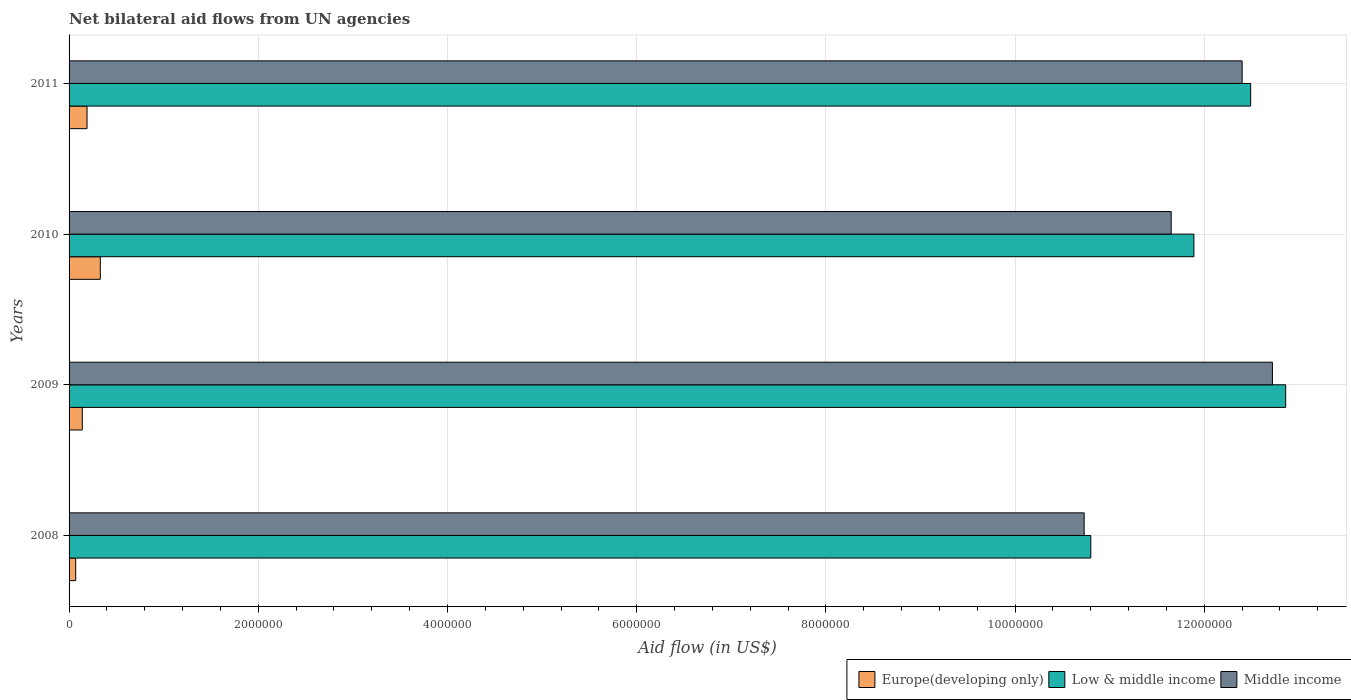How many different coloured bars are there?
Your response must be concise. 3. How many groups of bars are there?
Provide a short and direct response. 4. Are the number of bars per tick equal to the number of legend labels?
Your response must be concise. Yes. Are the number of bars on each tick of the Y-axis equal?
Ensure brevity in your answer.  Yes. How many bars are there on the 3rd tick from the top?
Offer a terse response. 3. What is the label of the 3rd group of bars from the top?
Make the answer very short. 2009. What is the net bilateral aid flow in Middle income in 2008?
Offer a very short reply. 1.07e+07. Across all years, what is the maximum net bilateral aid flow in Europe(developing only)?
Offer a terse response. 3.30e+05. Across all years, what is the minimum net bilateral aid flow in Low & middle income?
Provide a succinct answer. 1.08e+07. In which year was the net bilateral aid flow in Middle income maximum?
Keep it short and to the point. 2009. In which year was the net bilateral aid flow in Europe(developing only) minimum?
Make the answer very short. 2008. What is the total net bilateral aid flow in Europe(developing only) in the graph?
Ensure brevity in your answer.  7.30e+05. What is the difference between the net bilateral aid flow in Low & middle income in 2008 and that in 2009?
Your answer should be very brief. -2.06e+06. What is the difference between the net bilateral aid flow in Middle income in 2010 and the net bilateral aid flow in Europe(developing only) in 2008?
Provide a succinct answer. 1.16e+07. What is the average net bilateral aid flow in Europe(developing only) per year?
Provide a succinct answer. 1.82e+05. In the year 2009, what is the difference between the net bilateral aid flow in Low & middle income and net bilateral aid flow in Middle income?
Give a very brief answer. 1.40e+05. What is the ratio of the net bilateral aid flow in Middle income in 2008 to that in 2009?
Give a very brief answer. 0.84. Is the difference between the net bilateral aid flow in Low & middle income in 2009 and 2010 greater than the difference between the net bilateral aid flow in Middle income in 2009 and 2010?
Offer a very short reply. No. What is the difference between the highest and the lowest net bilateral aid flow in Low & middle income?
Make the answer very short. 2.06e+06. In how many years, is the net bilateral aid flow in Middle income greater than the average net bilateral aid flow in Middle income taken over all years?
Offer a very short reply. 2. Is the sum of the net bilateral aid flow in Middle income in 2009 and 2010 greater than the maximum net bilateral aid flow in Europe(developing only) across all years?
Offer a terse response. Yes. How many bars are there?
Your answer should be compact. 12. Are all the bars in the graph horizontal?
Your answer should be very brief. Yes. How many years are there in the graph?
Offer a very short reply. 4. Are the values on the major ticks of X-axis written in scientific E-notation?
Your response must be concise. No. Where does the legend appear in the graph?
Ensure brevity in your answer.  Bottom right. What is the title of the graph?
Your answer should be compact. Net bilateral aid flows from UN agencies. What is the label or title of the X-axis?
Make the answer very short. Aid flow (in US$). What is the label or title of the Y-axis?
Offer a terse response. Years. What is the Aid flow (in US$) of Low & middle income in 2008?
Ensure brevity in your answer.  1.08e+07. What is the Aid flow (in US$) of Middle income in 2008?
Make the answer very short. 1.07e+07. What is the Aid flow (in US$) of Europe(developing only) in 2009?
Your answer should be very brief. 1.40e+05. What is the Aid flow (in US$) of Low & middle income in 2009?
Your response must be concise. 1.29e+07. What is the Aid flow (in US$) in Middle income in 2009?
Your answer should be compact. 1.27e+07. What is the Aid flow (in US$) in Low & middle income in 2010?
Provide a short and direct response. 1.19e+07. What is the Aid flow (in US$) of Middle income in 2010?
Your answer should be compact. 1.16e+07. What is the Aid flow (in US$) of Europe(developing only) in 2011?
Offer a very short reply. 1.90e+05. What is the Aid flow (in US$) in Low & middle income in 2011?
Make the answer very short. 1.25e+07. What is the Aid flow (in US$) of Middle income in 2011?
Offer a terse response. 1.24e+07. Across all years, what is the maximum Aid flow (in US$) of Low & middle income?
Provide a succinct answer. 1.29e+07. Across all years, what is the maximum Aid flow (in US$) of Middle income?
Make the answer very short. 1.27e+07. Across all years, what is the minimum Aid flow (in US$) of Europe(developing only)?
Give a very brief answer. 7.00e+04. Across all years, what is the minimum Aid flow (in US$) in Low & middle income?
Offer a terse response. 1.08e+07. Across all years, what is the minimum Aid flow (in US$) in Middle income?
Provide a succinct answer. 1.07e+07. What is the total Aid flow (in US$) in Europe(developing only) in the graph?
Your answer should be very brief. 7.30e+05. What is the total Aid flow (in US$) in Low & middle income in the graph?
Your answer should be compact. 4.80e+07. What is the total Aid flow (in US$) in Middle income in the graph?
Make the answer very short. 4.75e+07. What is the difference between the Aid flow (in US$) in Europe(developing only) in 2008 and that in 2009?
Keep it short and to the point. -7.00e+04. What is the difference between the Aid flow (in US$) of Low & middle income in 2008 and that in 2009?
Offer a very short reply. -2.06e+06. What is the difference between the Aid flow (in US$) of Middle income in 2008 and that in 2009?
Provide a succinct answer. -1.99e+06. What is the difference between the Aid flow (in US$) in Europe(developing only) in 2008 and that in 2010?
Offer a terse response. -2.60e+05. What is the difference between the Aid flow (in US$) of Low & middle income in 2008 and that in 2010?
Keep it short and to the point. -1.09e+06. What is the difference between the Aid flow (in US$) in Middle income in 2008 and that in 2010?
Offer a terse response. -9.20e+05. What is the difference between the Aid flow (in US$) of Europe(developing only) in 2008 and that in 2011?
Offer a terse response. -1.20e+05. What is the difference between the Aid flow (in US$) of Low & middle income in 2008 and that in 2011?
Your response must be concise. -1.69e+06. What is the difference between the Aid flow (in US$) in Middle income in 2008 and that in 2011?
Give a very brief answer. -1.67e+06. What is the difference between the Aid flow (in US$) of Low & middle income in 2009 and that in 2010?
Ensure brevity in your answer.  9.70e+05. What is the difference between the Aid flow (in US$) in Middle income in 2009 and that in 2010?
Your answer should be very brief. 1.07e+06. What is the difference between the Aid flow (in US$) of Europe(developing only) in 2009 and that in 2011?
Provide a short and direct response. -5.00e+04. What is the difference between the Aid flow (in US$) in Middle income in 2009 and that in 2011?
Ensure brevity in your answer.  3.20e+05. What is the difference between the Aid flow (in US$) in Low & middle income in 2010 and that in 2011?
Ensure brevity in your answer.  -6.00e+05. What is the difference between the Aid flow (in US$) of Middle income in 2010 and that in 2011?
Keep it short and to the point. -7.50e+05. What is the difference between the Aid flow (in US$) in Europe(developing only) in 2008 and the Aid flow (in US$) in Low & middle income in 2009?
Your answer should be compact. -1.28e+07. What is the difference between the Aid flow (in US$) in Europe(developing only) in 2008 and the Aid flow (in US$) in Middle income in 2009?
Give a very brief answer. -1.26e+07. What is the difference between the Aid flow (in US$) of Low & middle income in 2008 and the Aid flow (in US$) of Middle income in 2009?
Provide a short and direct response. -1.92e+06. What is the difference between the Aid flow (in US$) in Europe(developing only) in 2008 and the Aid flow (in US$) in Low & middle income in 2010?
Your answer should be compact. -1.18e+07. What is the difference between the Aid flow (in US$) of Europe(developing only) in 2008 and the Aid flow (in US$) of Middle income in 2010?
Provide a succinct answer. -1.16e+07. What is the difference between the Aid flow (in US$) in Low & middle income in 2008 and the Aid flow (in US$) in Middle income in 2010?
Your response must be concise. -8.50e+05. What is the difference between the Aid flow (in US$) in Europe(developing only) in 2008 and the Aid flow (in US$) in Low & middle income in 2011?
Provide a short and direct response. -1.24e+07. What is the difference between the Aid flow (in US$) of Europe(developing only) in 2008 and the Aid flow (in US$) of Middle income in 2011?
Your response must be concise. -1.23e+07. What is the difference between the Aid flow (in US$) in Low & middle income in 2008 and the Aid flow (in US$) in Middle income in 2011?
Ensure brevity in your answer.  -1.60e+06. What is the difference between the Aid flow (in US$) in Europe(developing only) in 2009 and the Aid flow (in US$) in Low & middle income in 2010?
Give a very brief answer. -1.18e+07. What is the difference between the Aid flow (in US$) in Europe(developing only) in 2009 and the Aid flow (in US$) in Middle income in 2010?
Your answer should be very brief. -1.15e+07. What is the difference between the Aid flow (in US$) of Low & middle income in 2009 and the Aid flow (in US$) of Middle income in 2010?
Your answer should be very brief. 1.21e+06. What is the difference between the Aid flow (in US$) in Europe(developing only) in 2009 and the Aid flow (in US$) in Low & middle income in 2011?
Offer a terse response. -1.24e+07. What is the difference between the Aid flow (in US$) in Europe(developing only) in 2009 and the Aid flow (in US$) in Middle income in 2011?
Your answer should be very brief. -1.23e+07. What is the difference between the Aid flow (in US$) in Europe(developing only) in 2010 and the Aid flow (in US$) in Low & middle income in 2011?
Offer a terse response. -1.22e+07. What is the difference between the Aid flow (in US$) of Europe(developing only) in 2010 and the Aid flow (in US$) of Middle income in 2011?
Provide a short and direct response. -1.21e+07. What is the difference between the Aid flow (in US$) in Low & middle income in 2010 and the Aid flow (in US$) in Middle income in 2011?
Your answer should be compact. -5.10e+05. What is the average Aid flow (in US$) in Europe(developing only) per year?
Offer a terse response. 1.82e+05. What is the average Aid flow (in US$) of Low & middle income per year?
Ensure brevity in your answer.  1.20e+07. What is the average Aid flow (in US$) of Middle income per year?
Make the answer very short. 1.19e+07. In the year 2008, what is the difference between the Aid flow (in US$) in Europe(developing only) and Aid flow (in US$) in Low & middle income?
Keep it short and to the point. -1.07e+07. In the year 2008, what is the difference between the Aid flow (in US$) in Europe(developing only) and Aid flow (in US$) in Middle income?
Offer a very short reply. -1.07e+07. In the year 2009, what is the difference between the Aid flow (in US$) of Europe(developing only) and Aid flow (in US$) of Low & middle income?
Provide a succinct answer. -1.27e+07. In the year 2009, what is the difference between the Aid flow (in US$) in Europe(developing only) and Aid flow (in US$) in Middle income?
Keep it short and to the point. -1.26e+07. In the year 2009, what is the difference between the Aid flow (in US$) in Low & middle income and Aid flow (in US$) in Middle income?
Make the answer very short. 1.40e+05. In the year 2010, what is the difference between the Aid flow (in US$) of Europe(developing only) and Aid flow (in US$) of Low & middle income?
Give a very brief answer. -1.16e+07. In the year 2010, what is the difference between the Aid flow (in US$) of Europe(developing only) and Aid flow (in US$) of Middle income?
Provide a succinct answer. -1.13e+07. In the year 2010, what is the difference between the Aid flow (in US$) of Low & middle income and Aid flow (in US$) of Middle income?
Ensure brevity in your answer.  2.40e+05. In the year 2011, what is the difference between the Aid flow (in US$) in Europe(developing only) and Aid flow (in US$) in Low & middle income?
Keep it short and to the point. -1.23e+07. In the year 2011, what is the difference between the Aid flow (in US$) in Europe(developing only) and Aid flow (in US$) in Middle income?
Keep it short and to the point. -1.22e+07. What is the ratio of the Aid flow (in US$) of Europe(developing only) in 2008 to that in 2009?
Give a very brief answer. 0.5. What is the ratio of the Aid flow (in US$) in Low & middle income in 2008 to that in 2009?
Ensure brevity in your answer.  0.84. What is the ratio of the Aid flow (in US$) of Middle income in 2008 to that in 2009?
Make the answer very short. 0.84. What is the ratio of the Aid flow (in US$) in Europe(developing only) in 2008 to that in 2010?
Your answer should be compact. 0.21. What is the ratio of the Aid flow (in US$) of Low & middle income in 2008 to that in 2010?
Your answer should be very brief. 0.91. What is the ratio of the Aid flow (in US$) in Middle income in 2008 to that in 2010?
Give a very brief answer. 0.92. What is the ratio of the Aid flow (in US$) of Europe(developing only) in 2008 to that in 2011?
Offer a very short reply. 0.37. What is the ratio of the Aid flow (in US$) of Low & middle income in 2008 to that in 2011?
Ensure brevity in your answer.  0.86. What is the ratio of the Aid flow (in US$) in Middle income in 2008 to that in 2011?
Your answer should be compact. 0.87. What is the ratio of the Aid flow (in US$) of Europe(developing only) in 2009 to that in 2010?
Offer a terse response. 0.42. What is the ratio of the Aid flow (in US$) of Low & middle income in 2009 to that in 2010?
Your answer should be very brief. 1.08. What is the ratio of the Aid flow (in US$) of Middle income in 2009 to that in 2010?
Your answer should be compact. 1.09. What is the ratio of the Aid flow (in US$) in Europe(developing only) in 2009 to that in 2011?
Make the answer very short. 0.74. What is the ratio of the Aid flow (in US$) in Low & middle income in 2009 to that in 2011?
Make the answer very short. 1.03. What is the ratio of the Aid flow (in US$) of Middle income in 2009 to that in 2011?
Keep it short and to the point. 1.03. What is the ratio of the Aid flow (in US$) in Europe(developing only) in 2010 to that in 2011?
Offer a terse response. 1.74. What is the ratio of the Aid flow (in US$) in Low & middle income in 2010 to that in 2011?
Offer a very short reply. 0.95. What is the ratio of the Aid flow (in US$) in Middle income in 2010 to that in 2011?
Ensure brevity in your answer.  0.94. What is the difference between the highest and the lowest Aid flow (in US$) of Europe(developing only)?
Ensure brevity in your answer.  2.60e+05. What is the difference between the highest and the lowest Aid flow (in US$) of Low & middle income?
Offer a very short reply. 2.06e+06. What is the difference between the highest and the lowest Aid flow (in US$) of Middle income?
Make the answer very short. 1.99e+06. 